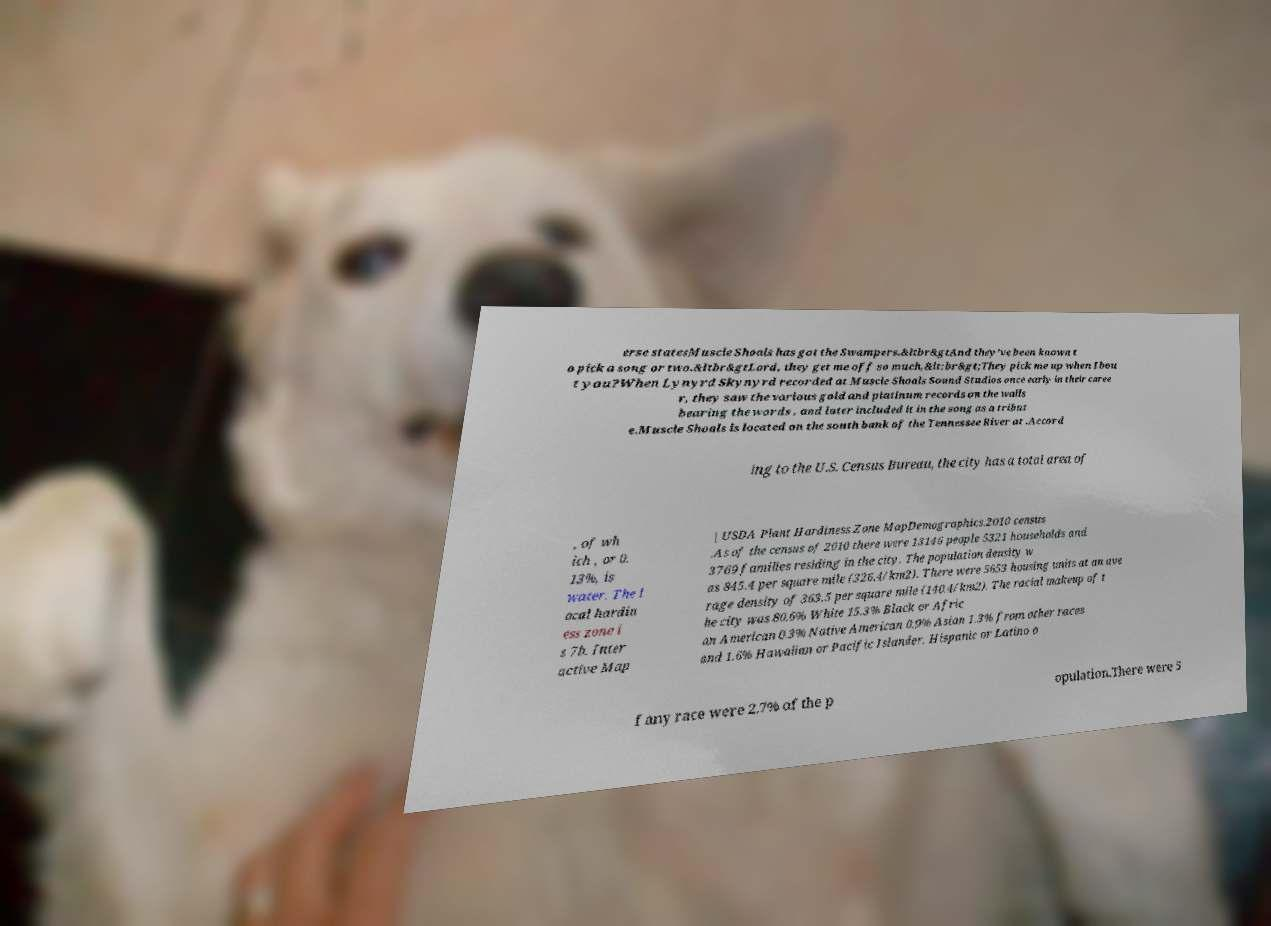For documentation purposes, I need the text within this image transcribed. Could you provide that? erse statesMuscle Shoals has got the Swampers.&ltbr&gtAnd they've been known t o pick a song or two.&ltbr&gtLord, they get me off so much,&lt;br&gt;They pick me up when Ibou t you?When Lynyrd Skynyrd recorded at Muscle Shoals Sound Studios once early in their caree r, they saw the various gold and platinum records on the walls bearing the words , and later included it in the song as a tribut e.Muscle Shoals is located on the south bank of the Tennessee River at .Accord ing to the U.S. Census Bureau, the city has a total area of , of wh ich , or 0. 13%, is water. The l ocal hardin ess zone i s 7b. Inter active Map | USDA Plant Hardiness Zone MapDemographics.2010 census .As of the census of 2010 there were 13146 people 5321 households and 3769 families residing in the city. The population density w as 845.4 per square mile (326.4/km2). There were 5653 housing units at an ave rage density of 363.5 per square mile (140.4/km2). The racial makeup of t he city was 80.6% White 15.3% Black or Afric an American 0.3% Native American 0.9% Asian 1.3% from other races and 1.6% Hawaiian or Pacific Islander. Hispanic or Latino o f any race were 2.7% of the p opulation.There were 5 